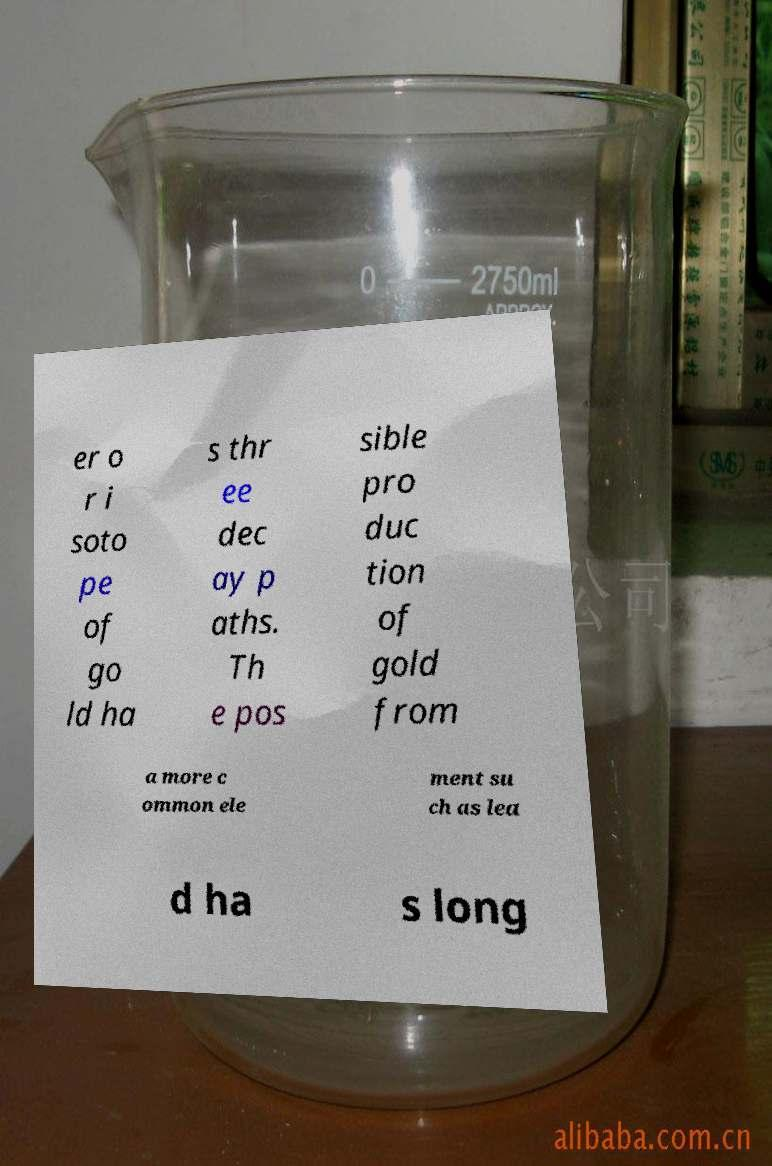Can you read and provide the text displayed in the image?This photo seems to have some interesting text. Can you extract and type it out for me? er o r i soto pe of go ld ha s thr ee dec ay p aths. Th e pos sible pro duc tion of gold from a more c ommon ele ment su ch as lea d ha s long 